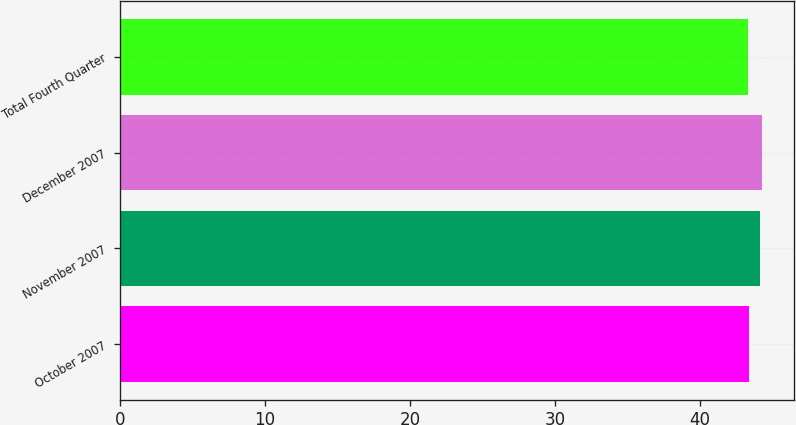<chart> <loc_0><loc_0><loc_500><loc_500><bar_chart><fcel>October 2007<fcel>November 2007<fcel>December 2007<fcel>Total Fourth Quarter<nl><fcel>43.36<fcel>44.16<fcel>44.25<fcel>43.27<nl></chart> 